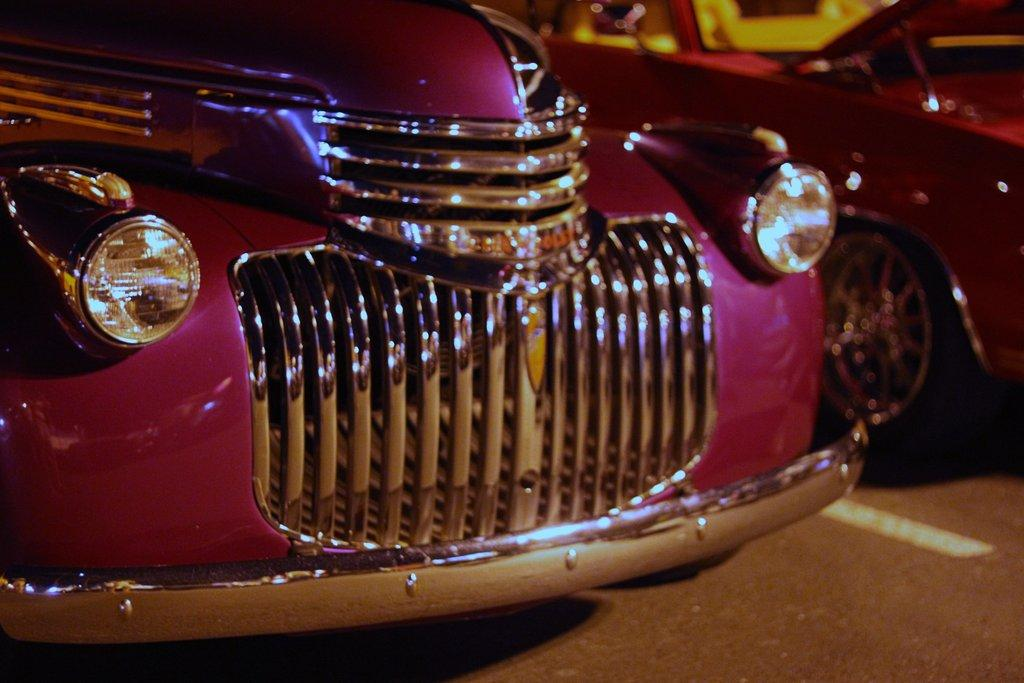What is the lighting condition in the image? The image was taken in the dark. What can be seen on the road in the image? There are two cars on the road in the image. What type of drum can be heard playing in the background of the image? There is no drum or sound present in the image, as it is a still photograph. 